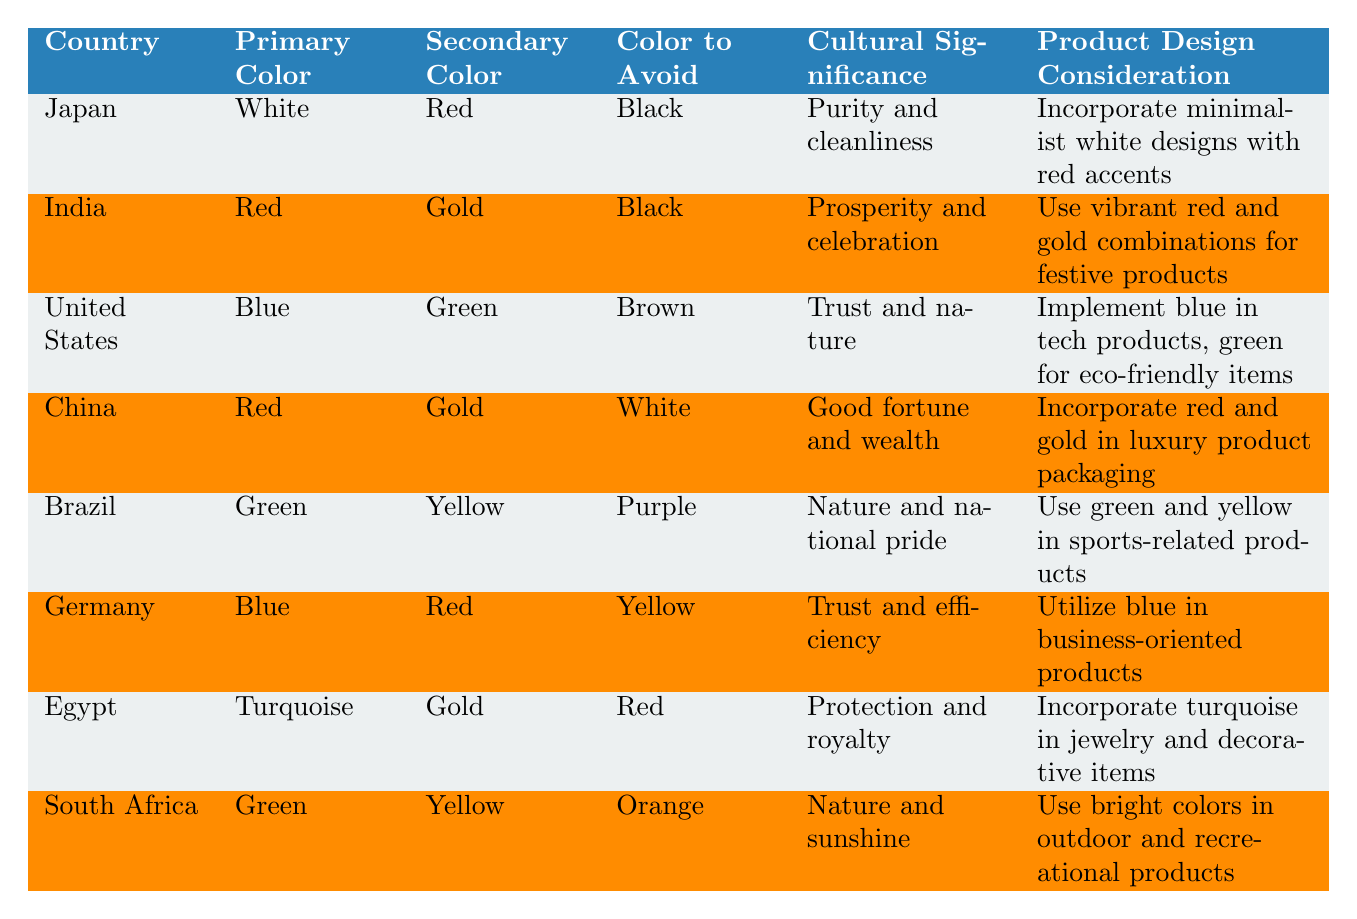What is the primary color preference in Japan? According to the table, the primary color preference in Japan is listed as "White."
Answer: White Which country prefers gold as a secondary color? The countries that prefer gold as a secondary color are India and China. Both are specifically mentioned in the table.
Answer: India, China What color should products avoid in India? The table indicates that the color to avoid in India is "Black."
Answer: Black Which country has turquoise as a primary color preference? The table shows that Egypt has turquoise as its primary color preference.
Answer: Egypt What are the color preferences for Brazil? Brazil's primary color preference is "Green" and the secondary color preference is "Yellow," as stated in the table.
Answer: Green, Yellow Do all countries in the table have the same color to avoid? No, the colors to avoid differ by country. For example, Japan avoids black, while China avoids white.
Answer: No Which country values trust and nature in their color preferences? The United States has blue as its primary color, reflecting trust, and green as a secondary color, aligning with nature.
Answer: United States What cultural significance is associated with the color red in China? The table mentions that in China, red symbolizes good fortune and wealth.
Answer: Good fortune and wealth Which country uses vibrant red and gold combinations for festive products? India is associated with using vibrant red and gold combinations for festive products, per the table.
Answer: India If a product is being designed for South Africa, which colors should be emphasized? Products for South Africa should emphasize bright colors, specifically green and yellow, according to the table's product design consideration.
Answer: Green, Yellow What is the most preferred primary color in Germany? The table indicates that Germany's primary color preference is "Blue."
Answer: Blue Which countries have red as their primary color preference? The countries with red as their primary color preference are India and China, as detailed in the table.
Answer: India, China What should be avoided in product designs for Egypt? The table states that red should be avoided in product designs for Egypt.
Answer: Red How does Brazil's color preference relate to nature? Brazil prefers green and yellow colors, which are associated with nature and national pride, as indicated by the cultural significance in the table.
Answer: Green, Yellow Is there any country that prefers purple? The table indicates that Brazil is listed as avoiding purple, implying no country has a primary or secondary preference for it.
Answer: No 